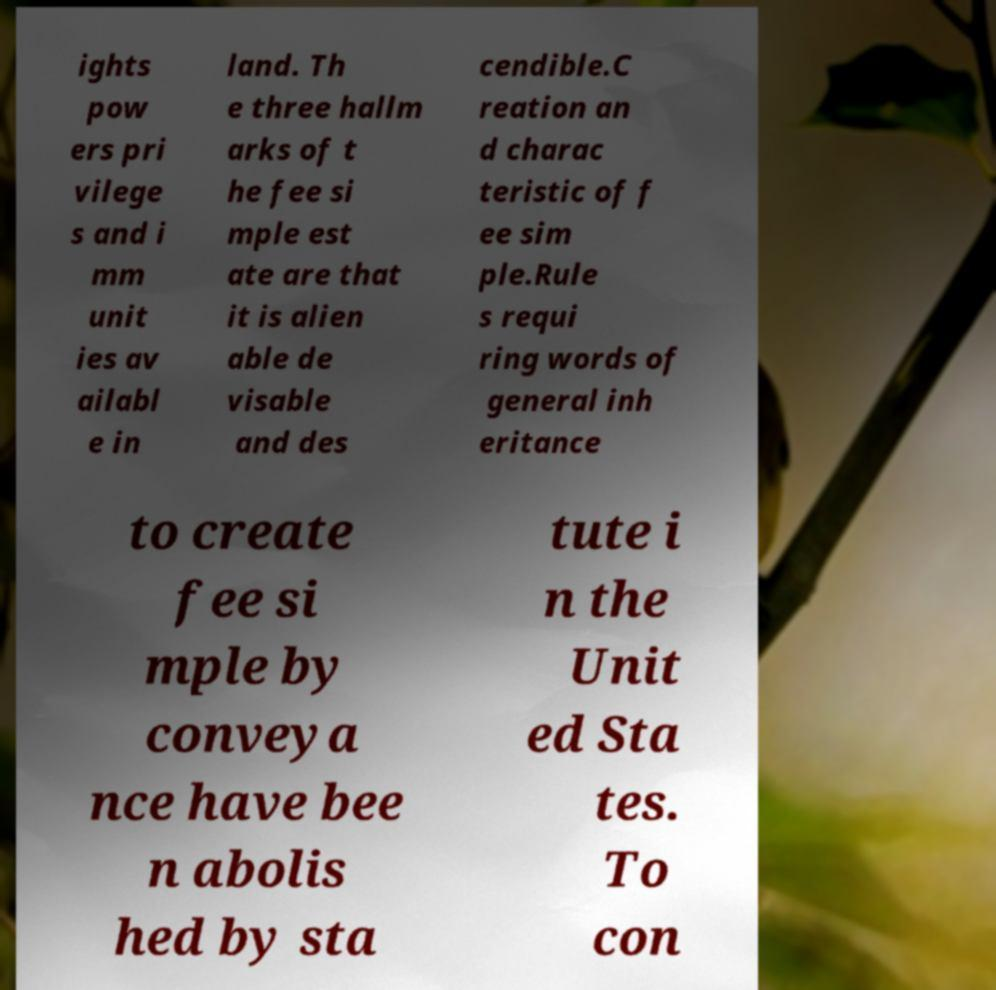I need the written content from this picture converted into text. Can you do that? ights pow ers pri vilege s and i mm unit ies av ailabl e in land. Th e three hallm arks of t he fee si mple est ate are that it is alien able de visable and des cendible.C reation an d charac teristic of f ee sim ple.Rule s requi ring words of general inh eritance to create fee si mple by conveya nce have bee n abolis hed by sta tute i n the Unit ed Sta tes. To con 